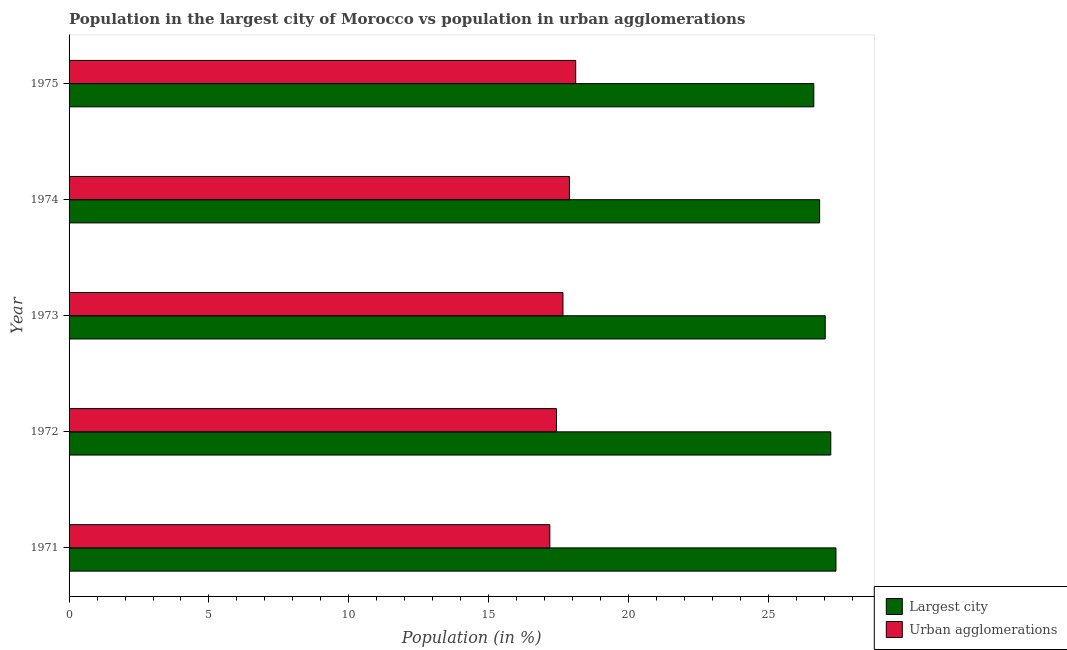How many different coloured bars are there?
Keep it short and to the point. 2. Are the number of bars on each tick of the Y-axis equal?
Make the answer very short. Yes. In how many cases, is the number of bars for a given year not equal to the number of legend labels?
Provide a short and direct response. 0. What is the population in urban agglomerations in 1973?
Ensure brevity in your answer.  17.66. Across all years, what is the maximum population in the largest city?
Ensure brevity in your answer.  27.41. Across all years, what is the minimum population in urban agglomerations?
Provide a succinct answer. 17.19. In which year was the population in urban agglomerations maximum?
Give a very brief answer. 1975. In which year was the population in urban agglomerations minimum?
Your answer should be very brief. 1971. What is the total population in the largest city in the graph?
Make the answer very short. 135.13. What is the difference between the population in urban agglomerations in 1972 and that in 1974?
Make the answer very short. -0.46. What is the difference between the population in urban agglomerations in 1975 and the population in the largest city in 1973?
Keep it short and to the point. -8.92. What is the average population in the largest city per year?
Ensure brevity in your answer.  27.02. In the year 1971, what is the difference between the population in the largest city and population in urban agglomerations?
Your answer should be very brief. 10.23. Is the difference between the population in urban agglomerations in 1974 and 1975 greater than the difference between the population in the largest city in 1974 and 1975?
Provide a short and direct response. No. What is the difference between the highest and the second highest population in the largest city?
Keep it short and to the point. 0.18. What is the difference between the highest and the lowest population in the largest city?
Make the answer very short. 0.79. In how many years, is the population in urban agglomerations greater than the average population in urban agglomerations taken over all years?
Provide a short and direct response. 3. What does the 2nd bar from the top in 1974 represents?
Your response must be concise. Largest city. What does the 1st bar from the bottom in 1974 represents?
Keep it short and to the point. Largest city. How many bars are there?
Make the answer very short. 10. Are all the bars in the graph horizontal?
Give a very brief answer. Yes. How many years are there in the graph?
Make the answer very short. 5. Does the graph contain any zero values?
Keep it short and to the point. No. Does the graph contain grids?
Offer a terse response. No. Where does the legend appear in the graph?
Your answer should be compact. Bottom right. How are the legend labels stacked?
Your answer should be compact. Vertical. What is the title of the graph?
Your answer should be very brief. Population in the largest city of Morocco vs population in urban agglomerations. What is the label or title of the X-axis?
Make the answer very short. Population (in %). What is the label or title of the Y-axis?
Give a very brief answer. Year. What is the Population (in %) of Largest city in 1971?
Your response must be concise. 27.41. What is the Population (in %) in Urban agglomerations in 1971?
Make the answer very short. 17.19. What is the Population (in %) in Largest city in 1972?
Ensure brevity in your answer.  27.23. What is the Population (in %) in Urban agglomerations in 1972?
Provide a short and direct response. 17.42. What is the Population (in %) in Largest city in 1973?
Your answer should be very brief. 27.03. What is the Population (in %) of Urban agglomerations in 1973?
Ensure brevity in your answer.  17.66. What is the Population (in %) of Largest city in 1974?
Make the answer very short. 26.83. What is the Population (in %) in Urban agglomerations in 1974?
Make the answer very short. 17.89. What is the Population (in %) in Largest city in 1975?
Ensure brevity in your answer.  26.62. What is the Population (in %) in Urban agglomerations in 1975?
Your answer should be very brief. 18.11. Across all years, what is the maximum Population (in %) of Largest city?
Provide a short and direct response. 27.41. Across all years, what is the maximum Population (in %) of Urban agglomerations?
Your answer should be compact. 18.11. Across all years, what is the minimum Population (in %) in Largest city?
Give a very brief answer. 26.62. Across all years, what is the minimum Population (in %) of Urban agglomerations?
Offer a terse response. 17.19. What is the total Population (in %) of Largest city in the graph?
Ensure brevity in your answer.  135.13. What is the total Population (in %) in Urban agglomerations in the graph?
Offer a terse response. 88.26. What is the difference between the Population (in %) of Largest city in 1971 and that in 1972?
Give a very brief answer. 0.18. What is the difference between the Population (in %) of Urban agglomerations in 1971 and that in 1972?
Offer a very short reply. -0.24. What is the difference between the Population (in %) in Largest city in 1971 and that in 1973?
Ensure brevity in your answer.  0.38. What is the difference between the Population (in %) of Urban agglomerations in 1971 and that in 1973?
Your response must be concise. -0.47. What is the difference between the Population (in %) of Largest city in 1971 and that in 1974?
Give a very brief answer. 0.58. What is the difference between the Population (in %) of Urban agglomerations in 1971 and that in 1974?
Your answer should be very brief. -0.7. What is the difference between the Population (in %) of Largest city in 1971 and that in 1975?
Make the answer very short. 0.79. What is the difference between the Population (in %) in Urban agglomerations in 1971 and that in 1975?
Make the answer very short. -0.93. What is the difference between the Population (in %) in Largest city in 1972 and that in 1973?
Your answer should be very brief. 0.2. What is the difference between the Population (in %) in Urban agglomerations in 1972 and that in 1973?
Your response must be concise. -0.23. What is the difference between the Population (in %) of Largest city in 1972 and that in 1974?
Make the answer very short. 0.4. What is the difference between the Population (in %) of Urban agglomerations in 1972 and that in 1974?
Offer a very short reply. -0.46. What is the difference between the Population (in %) of Largest city in 1972 and that in 1975?
Keep it short and to the point. 0.61. What is the difference between the Population (in %) in Urban agglomerations in 1972 and that in 1975?
Your response must be concise. -0.69. What is the difference between the Population (in %) of Largest city in 1973 and that in 1974?
Give a very brief answer. 0.2. What is the difference between the Population (in %) in Urban agglomerations in 1973 and that in 1974?
Offer a terse response. -0.23. What is the difference between the Population (in %) in Largest city in 1973 and that in 1975?
Your response must be concise. 0.41. What is the difference between the Population (in %) of Urban agglomerations in 1973 and that in 1975?
Your response must be concise. -0.46. What is the difference between the Population (in %) of Largest city in 1974 and that in 1975?
Offer a terse response. 0.21. What is the difference between the Population (in %) of Urban agglomerations in 1974 and that in 1975?
Offer a terse response. -0.22. What is the difference between the Population (in %) in Largest city in 1971 and the Population (in %) in Urban agglomerations in 1972?
Provide a short and direct response. 9.99. What is the difference between the Population (in %) in Largest city in 1971 and the Population (in %) in Urban agglomerations in 1973?
Provide a succinct answer. 9.76. What is the difference between the Population (in %) in Largest city in 1971 and the Population (in %) in Urban agglomerations in 1974?
Keep it short and to the point. 9.53. What is the difference between the Population (in %) of Largest city in 1971 and the Population (in %) of Urban agglomerations in 1975?
Provide a succinct answer. 9.3. What is the difference between the Population (in %) in Largest city in 1972 and the Population (in %) in Urban agglomerations in 1973?
Ensure brevity in your answer.  9.57. What is the difference between the Population (in %) of Largest city in 1972 and the Population (in %) of Urban agglomerations in 1974?
Ensure brevity in your answer.  9.34. What is the difference between the Population (in %) of Largest city in 1972 and the Population (in %) of Urban agglomerations in 1975?
Provide a short and direct response. 9.12. What is the difference between the Population (in %) of Largest city in 1973 and the Population (in %) of Urban agglomerations in 1974?
Your response must be concise. 9.14. What is the difference between the Population (in %) in Largest city in 1973 and the Population (in %) in Urban agglomerations in 1975?
Ensure brevity in your answer.  8.92. What is the difference between the Population (in %) in Largest city in 1974 and the Population (in %) in Urban agglomerations in 1975?
Keep it short and to the point. 8.72. What is the average Population (in %) in Largest city per year?
Provide a short and direct response. 27.03. What is the average Population (in %) in Urban agglomerations per year?
Give a very brief answer. 17.65. In the year 1971, what is the difference between the Population (in %) in Largest city and Population (in %) in Urban agglomerations?
Your answer should be compact. 10.23. In the year 1972, what is the difference between the Population (in %) in Largest city and Population (in %) in Urban agglomerations?
Offer a very short reply. 9.81. In the year 1973, what is the difference between the Population (in %) of Largest city and Population (in %) of Urban agglomerations?
Offer a terse response. 9.37. In the year 1974, what is the difference between the Population (in %) of Largest city and Population (in %) of Urban agglomerations?
Your response must be concise. 8.94. In the year 1975, what is the difference between the Population (in %) in Largest city and Population (in %) in Urban agglomerations?
Ensure brevity in your answer.  8.51. What is the ratio of the Population (in %) of Largest city in 1971 to that in 1972?
Offer a terse response. 1.01. What is the ratio of the Population (in %) of Urban agglomerations in 1971 to that in 1972?
Your answer should be very brief. 0.99. What is the ratio of the Population (in %) in Largest city in 1971 to that in 1973?
Your response must be concise. 1.01. What is the ratio of the Population (in %) in Urban agglomerations in 1971 to that in 1973?
Your response must be concise. 0.97. What is the ratio of the Population (in %) in Largest city in 1971 to that in 1974?
Keep it short and to the point. 1.02. What is the ratio of the Population (in %) in Urban agglomerations in 1971 to that in 1974?
Keep it short and to the point. 0.96. What is the ratio of the Population (in %) in Largest city in 1971 to that in 1975?
Your answer should be very brief. 1.03. What is the ratio of the Population (in %) of Urban agglomerations in 1971 to that in 1975?
Offer a very short reply. 0.95. What is the ratio of the Population (in %) of Largest city in 1972 to that in 1973?
Your answer should be very brief. 1.01. What is the ratio of the Population (in %) of Urban agglomerations in 1972 to that in 1973?
Provide a succinct answer. 0.99. What is the ratio of the Population (in %) in Largest city in 1972 to that in 1974?
Your answer should be compact. 1.01. What is the ratio of the Population (in %) of Urban agglomerations in 1972 to that in 1974?
Your answer should be very brief. 0.97. What is the ratio of the Population (in %) in Largest city in 1972 to that in 1975?
Give a very brief answer. 1.02. What is the ratio of the Population (in %) of Urban agglomerations in 1972 to that in 1975?
Your response must be concise. 0.96. What is the ratio of the Population (in %) in Largest city in 1973 to that in 1974?
Make the answer very short. 1.01. What is the ratio of the Population (in %) of Urban agglomerations in 1973 to that in 1974?
Your answer should be compact. 0.99. What is the ratio of the Population (in %) of Largest city in 1973 to that in 1975?
Offer a very short reply. 1.02. What is the ratio of the Population (in %) in Urban agglomerations in 1973 to that in 1975?
Your answer should be compact. 0.97. What is the ratio of the Population (in %) of Urban agglomerations in 1974 to that in 1975?
Make the answer very short. 0.99. What is the difference between the highest and the second highest Population (in %) of Largest city?
Keep it short and to the point. 0.18. What is the difference between the highest and the second highest Population (in %) of Urban agglomerations?
Keep it short and to the point. 0.22. What is the difference between the highest and the lowest Population (in %) of Largest city?
Keep it short and to the point. 0.79. What is the difference between the highest and the lowest Population (in %) in Urban agglomerations?
Your response must be concise. 0.93. 